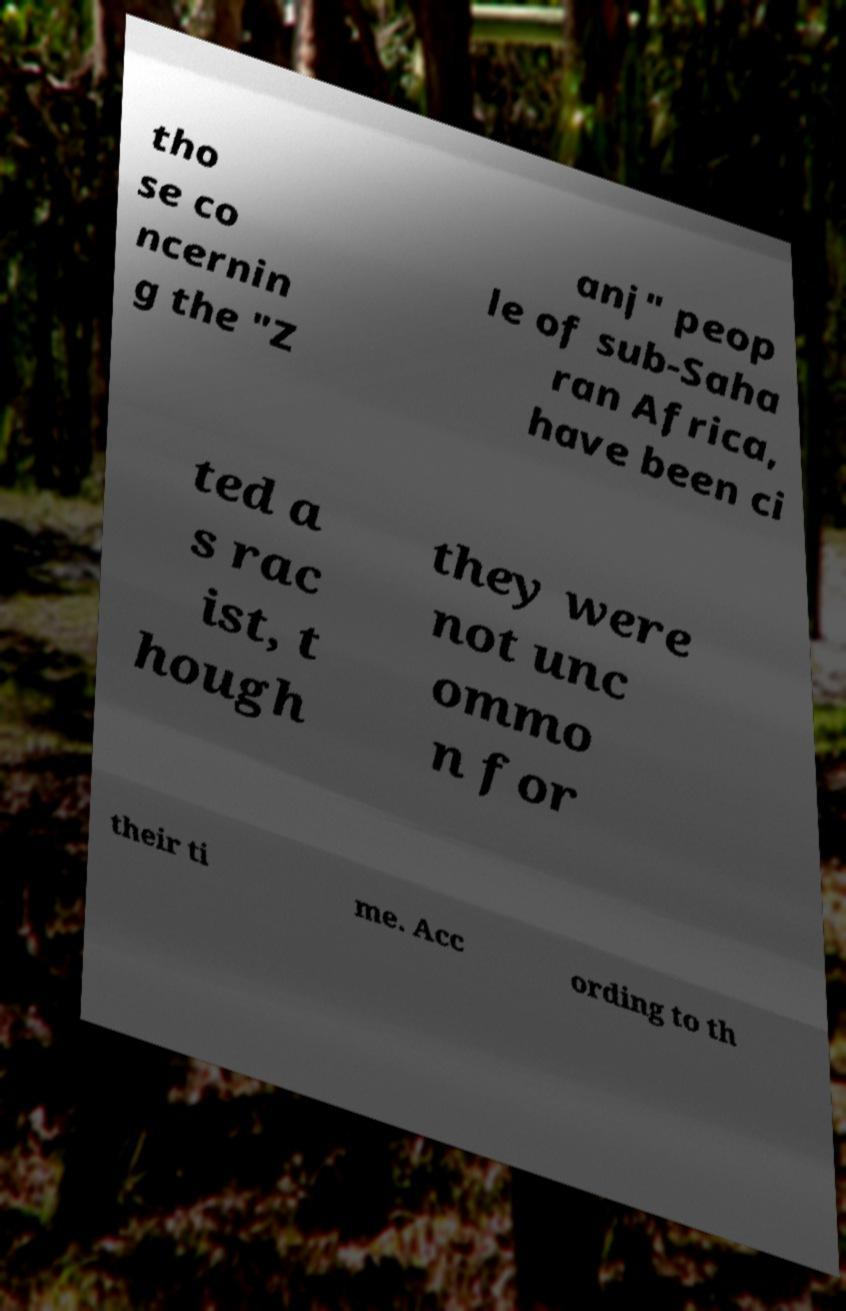Can you accurately transcribe the text from the provided image for me? tho se co ncernin g the "Z anj" peop le of sub-Saha ran Africa, have been ci ted a s rac ist, t hough they were not unc ommo n for their ti me. Acc ording to th 